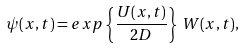<formula> <loc_0><loc_0><loc_500><loc_500>\psi ( x , t ) = e x p \left \{ \frac { U ( x , t ) } { 2 D } \right \} \, W ( x , t ) ,</formula> 